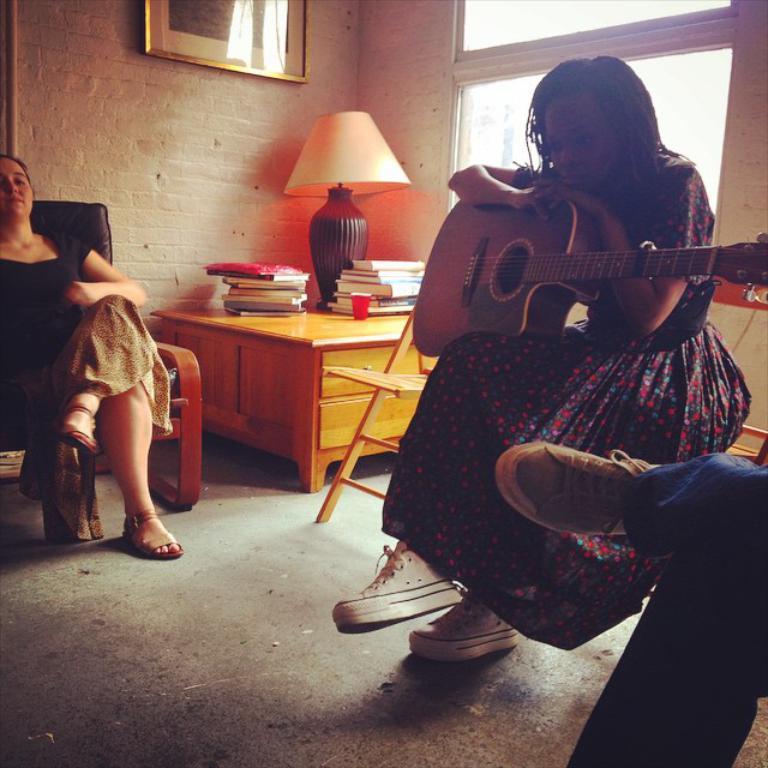Can you describe this image briefly? There is a room. The three peoples are sitting on a chairs. In the center we have a woman. She is holding a guitar. There is a table. There is a glass,bottle,lamp on a table. We can see in background photo frame, window and red wall brick. 